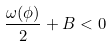<formula> <loc_0><loc_0><loc_500><loc_500>\frac { \omega ( \phi ) } { 2 } + B < 0</formula> 